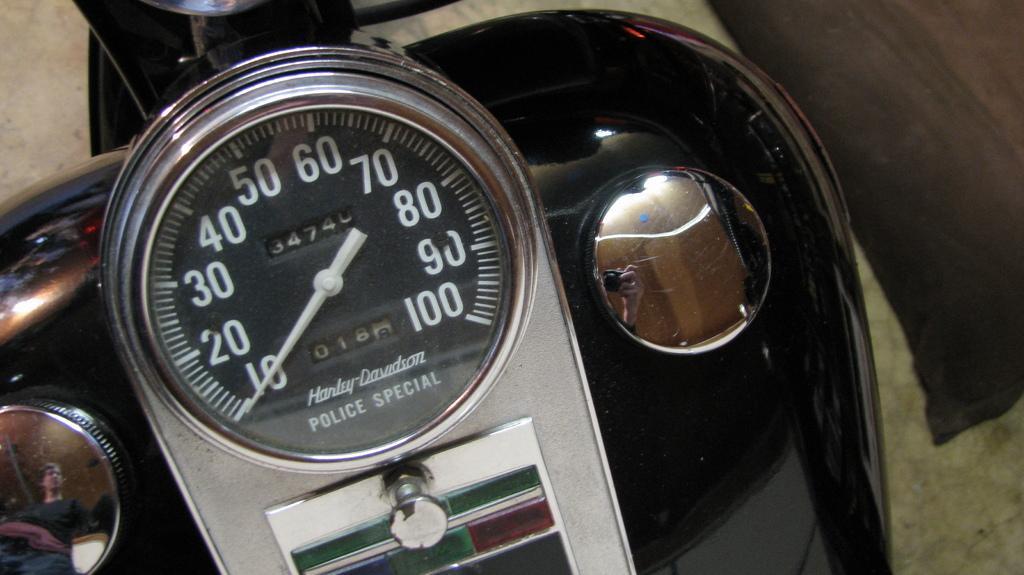Please provide a concise description of this image. In the center of the image we can see speedometer on the vehicle. 